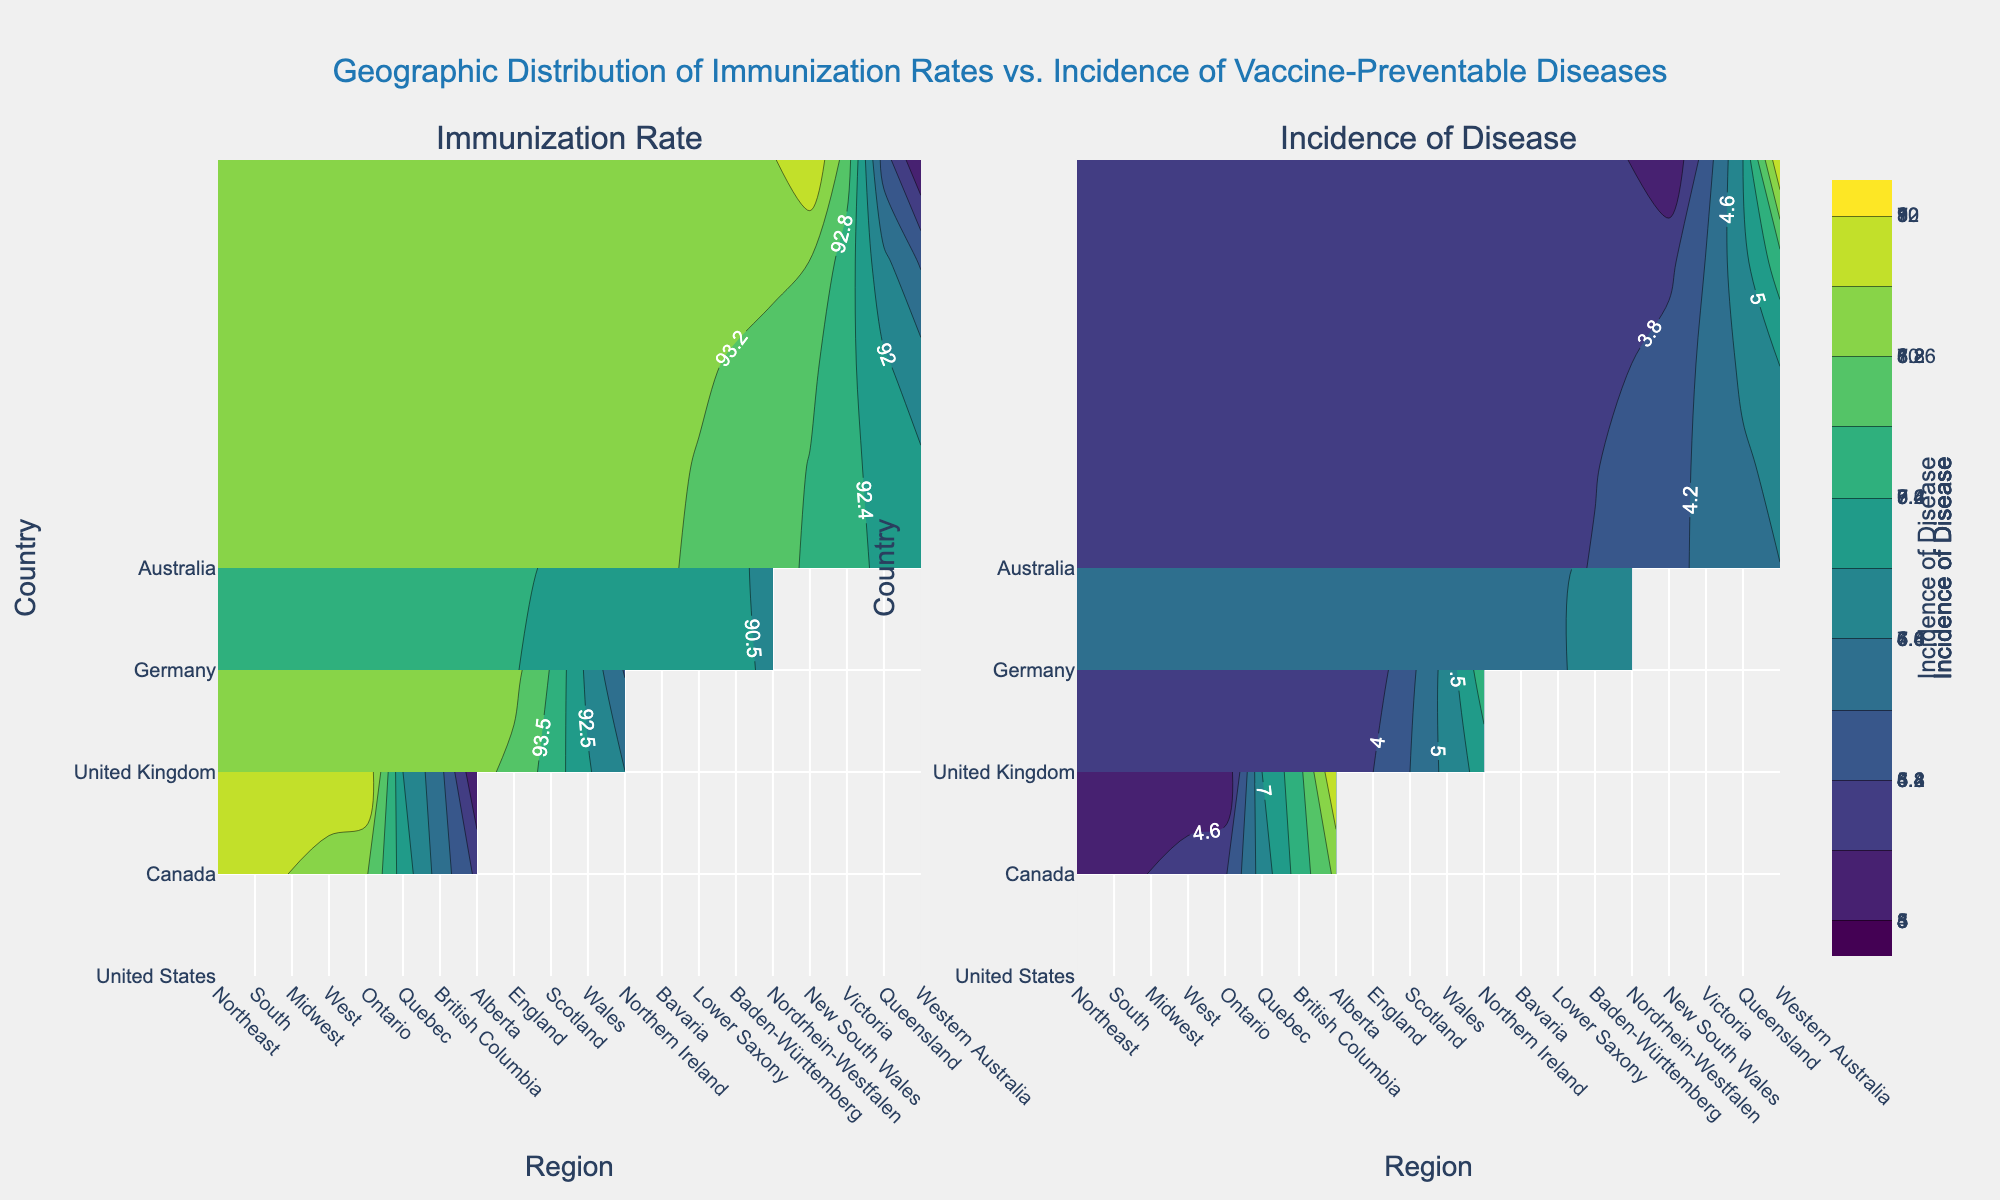What is the title of the figure? The title is located at the top center of the figure.
Answer: Geographic Distribution of Immunization Rates vs. Incidence of Vaccine-Preventable Diseases What are the two metrics displayed in the subplots? The subplot titles above each plot indicate the metrics displayed. One subplot shows "Immunization Rate" and the other shows "Incidence of Disease".
Answer: Immunization Rate, Incidence of Disease Which country has the highest immunization rate? In the "Immunization Rate" subplot, the highest immunization rate is represented by the darkest color. By comparing the color scales for each country, identify the country with the highest value.
Answer: United Kingdom How does the incidence of disease in the South of the United States compare to its immunization rate? Look at the color shading in both the "Incidence of Disease" and "Immunization Rate" subplots for the South region of the United States. The South has a relatively low immunization rate indicated by lighter shading, and a high incidence of disease indicated by darker shading.
Answer: Lower immunization rate, higher incidence of disease Which region in Canada has the lowest immunization rate, and what is its incidence of disease? Identify the region with the lightest shading in the "Immunization Rate" subplot for Canada and then look at the corresponding shading in the "Incidence of Disease" subplot. Alberta has the lowest immunization rate and a high incidence of disease.
Answer: Alberta, 10 What is the immunization rate range in Germany according to the figure? The contour lines in the "Immunization Rate" subplot show the minimum and maximum values for Germany. Compare the shading colors and lines to determine the range.
Answer: 89-92 In which region and country is the incidence of disease the lowest? Check the "Incidence of Disease" subplot for the region with the lightest color, indicating the lowest value, and note the corresponding country. New South Wales in Australia has an incidence of 3.
Answer: New South Wales, Australia Compare the immunization rates between Ontario and Quebec in Canada. Which has a higher rate and by how much? In the "Immunization Rate" subplot, compare the shading for Ontario and Quebec. Ontario has a slightly darker shading than Quebec, indicating a higher rate. The difference can be identified by the contour lines.
Answer: Ontario has a higher rate by 3 (93 vs. 90) 